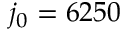<formula> <loc_0><loc_0><loc_500><loc_500>j _ { 0 } = 6 2 5 0</formula> 